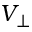<formula> <loc_0><loc_0><loc_500><loc_500>V _ { \perp }</formula> 